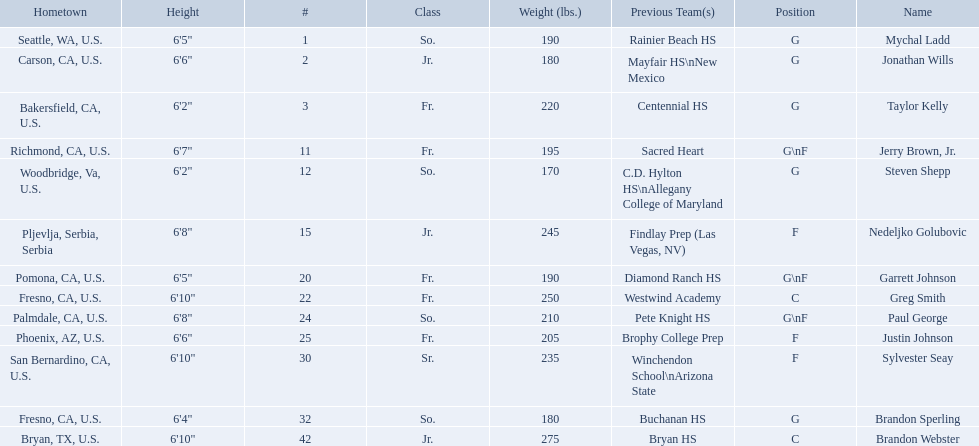Who are the players for the 2009-10 fresno state bulldogs men's basketball team? Mychal Ladd, Jonathan Wills, Taylor Kelly, Jerry Brown, Jr., Steven Shepp, Nedeljko Golubovic, Garrett Johnson, Greg Smith, Paul George, Justin Johnson, Sylvester Seay, Brandon Sperling, Brandon Webster. What are their heights? 6'5", 6'6", 6'2", 6'7", 6'2", 6'8", 6'5", 6'10", 6'8", 6'6", 6'10", 6'4", 6'10". What is the shortest height? 6'2", 6'2". What is the lowest weight? 6'2". Which player is it? Steven Shepp. What are the names of the basketball team players? Mychal Ladd, Jonathan Wills, Taylor Kelly, Jerry Brown, Jr., Steven Shepp, Nedeljko Golubovic, Garrett Johnson, Greg Smith, Paul George, Justin Johnson, Sylvester Seay, Brandon Sperling, Brandon Webster. Of these identify paul george and greg smith Greg Smith, Paul George. What are their corresponding heights? 6'10", 6'8". To who does the larger height correspond to? Greg Smith. Who are all of the players? Mychal Ladd, Jonathan Wills, Taylor Kelly, Jerry Brown, Jr., Steven Shepp, Nedeljko Golubovic, Garrett Johnson, Greg Smith, Paul George, Justin Johnson, Sylvester Seay, Brandon Sperling, Brandon Webster. What are their heights? 6'5", 6'6", 6'2", 6'7", 6'2", 6'8", 6'5", 6'10", 6'8", 6'6", 6'10", 6'4", 6'10". Along with taylor kelly, which other player is shorter than 6'3? Steven Shepp. Who are all the players? Mychal Ladd, Jonathan Wills, Taylor Kelly, Jerry Brown, Jr., Steven Shepp, Nedeljko Golubovic, Garrett Johnson, Greg Smith, Paul George, Justin Johnson, Sylvester Seay, Brandon Sperling, Brandon Webster. How tall are they? 6'5", 6'6", 6'2", 6'7", 6'2", 6'8", 6'5", 6'10", 6'8", 6'6", 6'10", 6'4", 6'10". What about just paul george and greg smitih? 6'10", 6'8". And which of the two is taller? Greg Smith. 